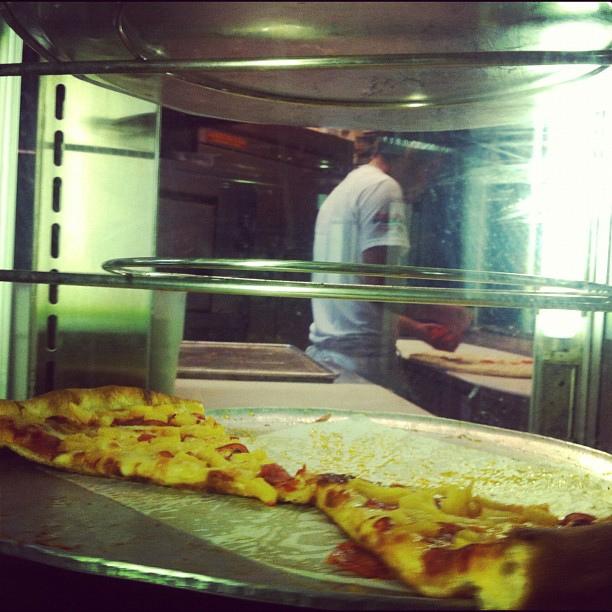What is the man doing?
Short answer required. Making pizza. What kind of fruit is on the pizza?
Give a very brief answer. Pineapple. Is the pizza hot?
Be succinct. Yes. 